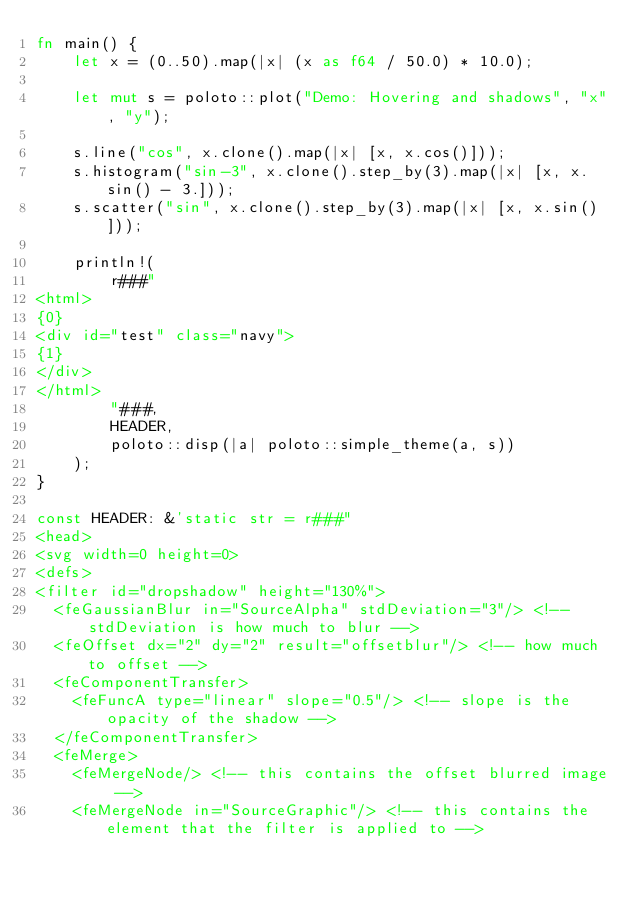Convert code to text. <code><loc_0><loc_0><loc_500><loc_500><_Rust_>fn main() {
    let x = (0..50).map(|x| (x as f64 / 50.0) * 10.0);

    let mut s = poloto::plot("Demo: Hovering and shadows", "x", "y");

    s.line("cos", x.clone().map(|x| [x, x.cos()]));
    s.histogram("sin-3", x.clone().step_by(3).map(|x| [x, x.sin() - 3.]));
    s.scatter("sin", x.clone().step_by(3).map(|x| [x, x.sin()]));

    println!(
        r###"
<html>
{0}
<div id="test" class="navy">
{1}
</div>
</html>
        "###,
        HEADER,
        poloto::disp(|a| poloto::simple_theme(a, s))
    );
}

const HEADER: &'static str = r###"
<head>
<svg width=0 height=0>
<defs>
<filter id="dropshadow" height="130%">
  <feGaussianBlur in="SourceAlpha" stdDeviation="3"/> <!-- stdDeviation is how much to blur -->
  <feOffset dx="2" dy="2" result="offsetblur"/> <!-- how much to offset -->
  <feComponentTransfer>
    <feFuncA type="linear" slope="0.5"/> <!-- slope is the opacity of the shadow -->
  </feComponentTransfer>
  <feMerge> 
    <feMergeNode/> <!-- this contains the offset blurred image -->
    <feMergeNode in="SourceGraphic"/> <!-- this contains the element that the filter is applied to --></code> 